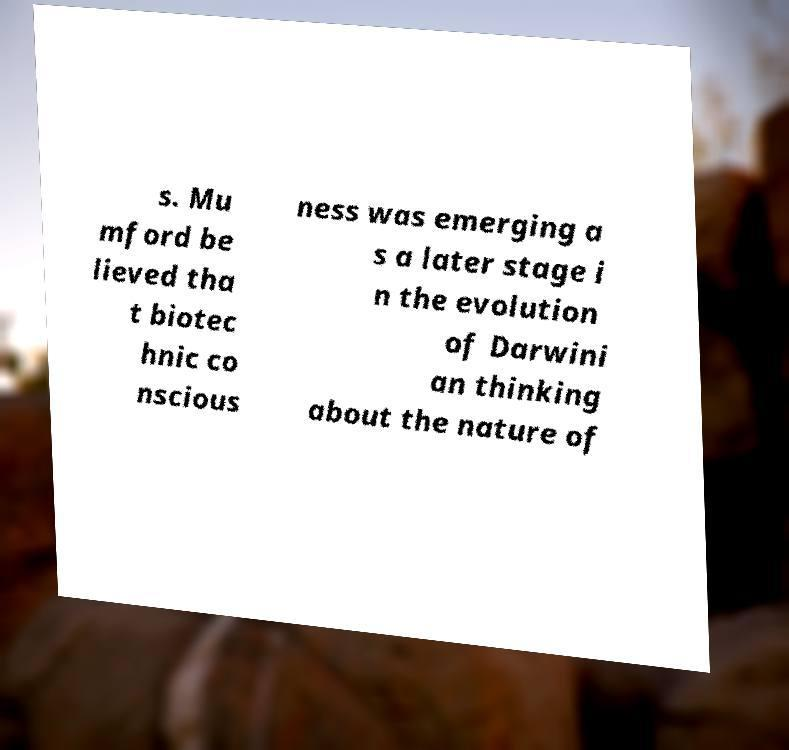For documentation purposes, I need the text within this image transcribed. Could you provide that? s. Mu mford be lieved tha t biotec hnic co nscious ness was emerging a s a later stage i n the evolution of Darwini an thinking about the nature of 